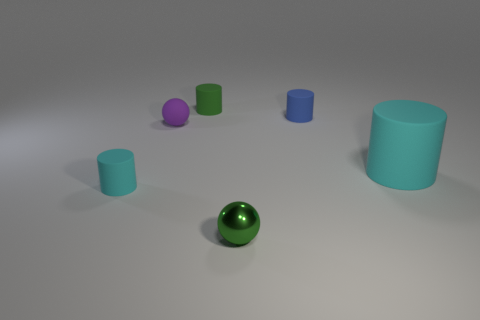Is there a small ball that has the same color as the big rubber cylinder?
Offer a terse response. No. What color is the matte cylinder that is in front of the cyan cylinder right of the sphere that is in front of the big rubber cylinder?
Keep it short and to the point. Cyan. Is the material of the large cylinder the same as the tiny sphere behind the tiny green shiny thing?
Make the answer very short. Yes. What material is the green ball?
Keep it short and to the point. Metal. How many other objects are there of the same material as the big cyan cylinder?
Offer a terse response. 4. What is the shape of the rubber thing that is on the right side of the green shiny sphere and on the left side of the big rubber cylinder?
Provide a succinct answer. Cylinder. The ball that is made of the same material as the green cylinder is what color?
Ensure brevity in your answer.  Purple. Are there an equal number of small green metal things behind the tiny green ball and large red matte balls?
Provide a succinct answer. Yes. There is a purple object that is the same size as the green metal thing; what shape is it?
Offer a very short reply. Sphere. What number of other objects are the same shape as the big cyan matte thing?
Ensure brevity in your answer.  3. 